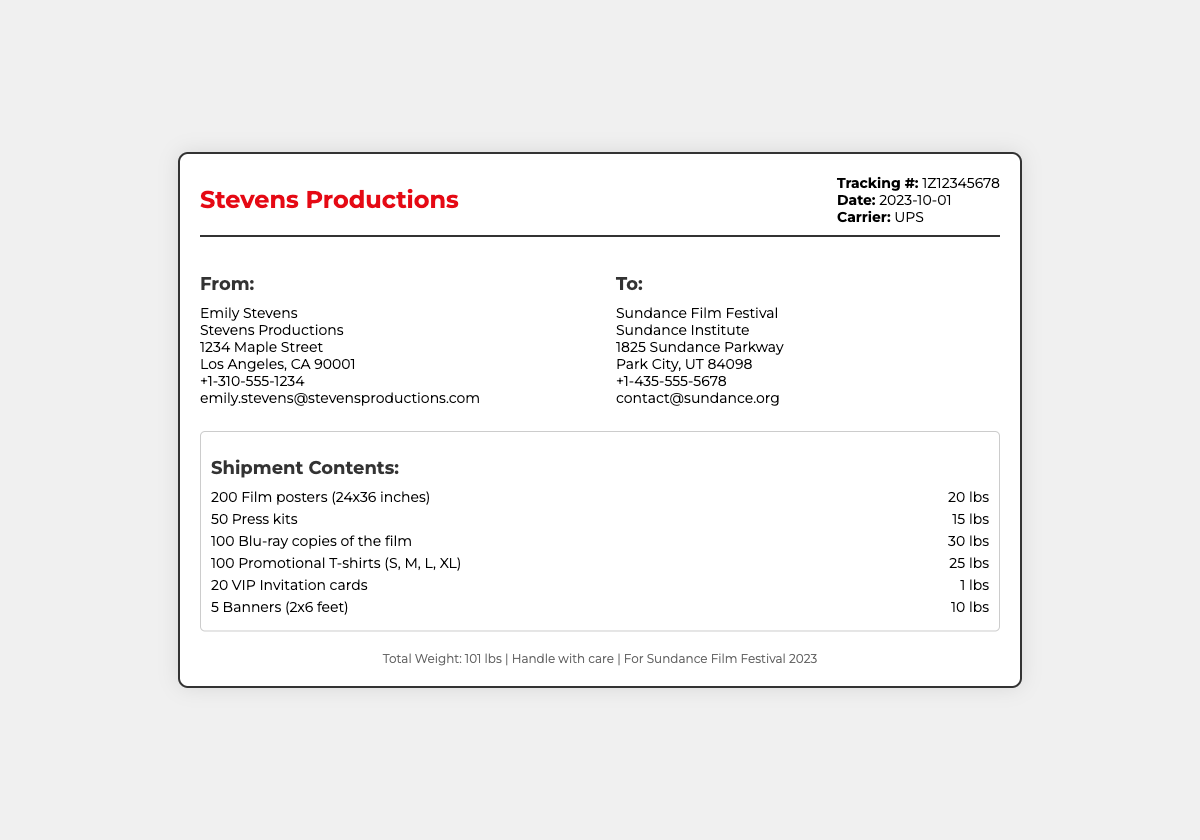What is the tracking number? The tracking number is provided in the shipping label under the Tracking section.
Answer: 1Z12345678 Who is the sender? The sender's name appears at the top of the 'From' address section in the document.
Answer: Emily Stevens What is the date of shipment? The date of shipment can be found in the Tracking section of the shipping label.
Answer: 2023-10-01 How many film posters are included in the shipment? The quantity of film posters is listed under the Shipment Contents section.
Answer: 200 What is the total weight of the shipment? The total weight is summarized in the footer of the shipping label.
Answer: 101 lbs How many Blu-ray copies of the film are being shipped? The quantity of Blu-ray copies is indicated in the items section of the shipping label.
Answer: 100 What type of items are included in the shipment? The items included can be inferred from the 'Shipment Contents' section.
Answer: Film posters, Press kits, Blu-ray copies, T-shirts, Invitation cards, Banners What is the purpose of this shipment? The purpose is implied from the shipment's destination noted in the 'To' address section.
Answer: For Sundance Film Festival 2023 How many VIP Invitation cards are included? The number of VIP Invitation cards can be found in the items listed in the document.
Answer: 20 What is the carrier used for this shipment? The carrier's name is mentioned in the Tracking section of the shipping label.
Answer: UPS 